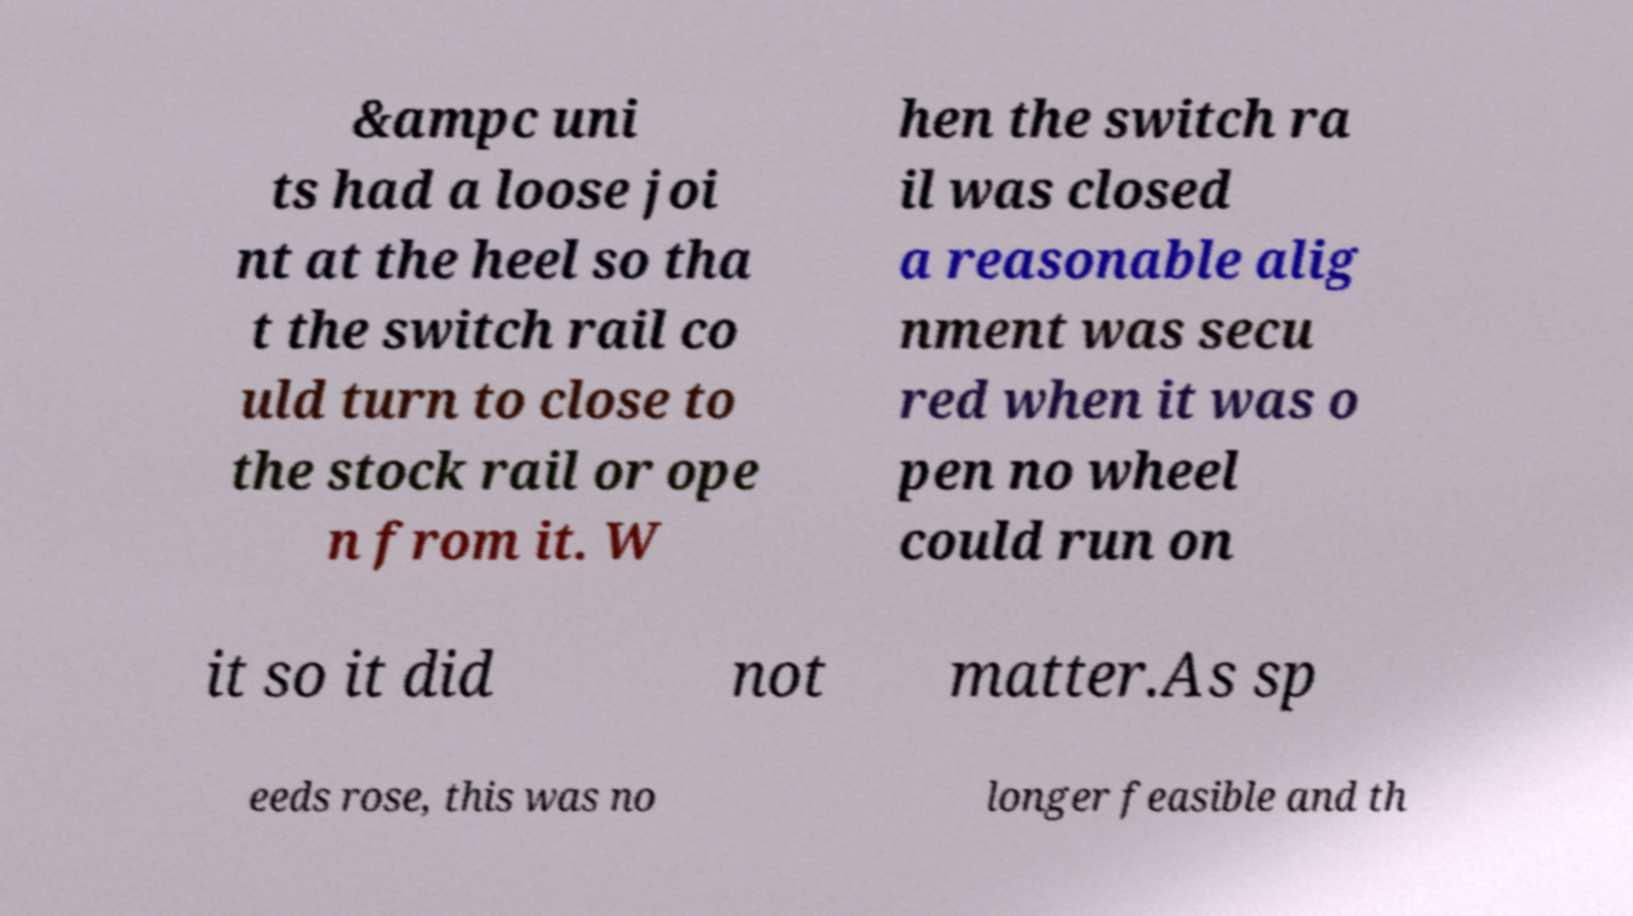Could you assist in decoding the text presented in this image and type it out clearly? &ampc uni ts had a loose joi nt at the heel so tha t the switch rail co uld turn to close to the stock rail or ope n from it. W hen the switch ra il was closed a reasonable alig nment was secu red when it was o pen no wheel could run on it so it did not matter.As sp eeds rose, this was no longer feasible and th 